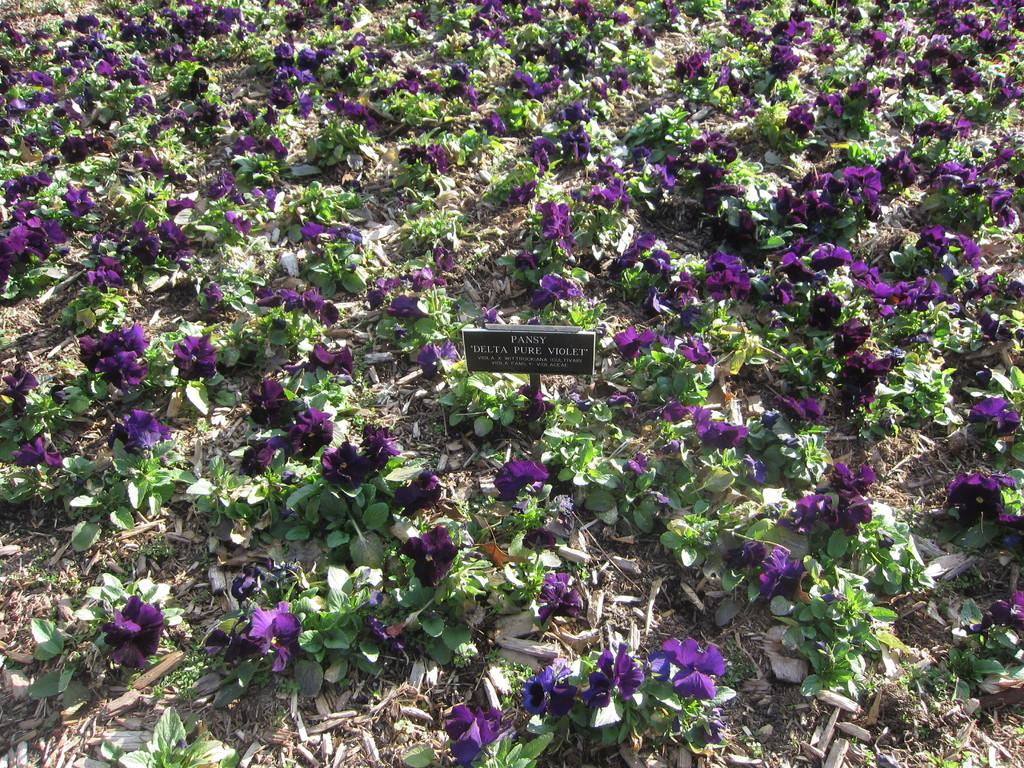What type of living organisms can be seen in the image? There are flowers and plants visible in the image. What might be the purpose of the flowers and plants in the image? The flowers and plants could be part of a garden or landscape. What can be observed on the surface in the image? Dry leaves are present on the surface in the image. What type of drug is being sold in the image? There is no indication of any drug being sold or present in the image. The image features flowers, plants, and dry leaves. 